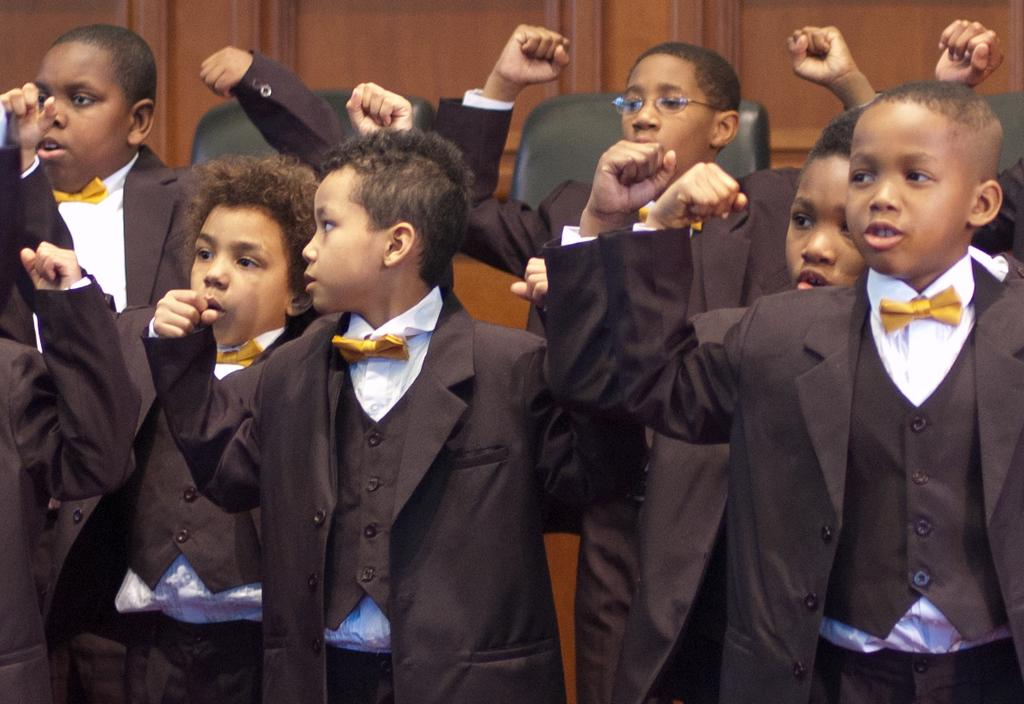Who is present in the image? There are kids in the image. What are the kids doing in the image? The kids are standing. What are the kids wearing in the image? The kids are wearing black color coats. What else can be seen in the image? There are chairs in the image. What type of engine can be seen in the image? There is no engine present in the image. Can you tell me how many buckets are visible in the image? There are no buckets visible in the image. 